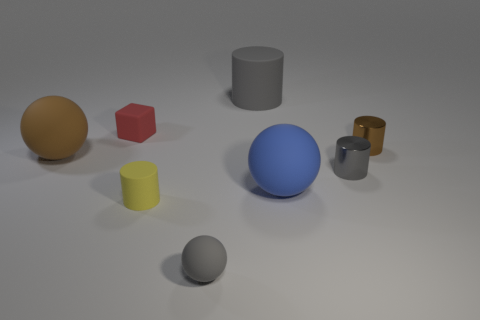Subtract all gray spheres. How many spheres are left? 2 Add 2 small metal cylinders. How many objects exist? 10 Subtract all yellow blocks. Subtract all purple spheres. How many blocks are left? 1 Subtract all brown blocks. How many yellow cylinders are left? 1 Subtract all small gray matte spheres. Subtract all brown metallic cylinders. How many objects are left? 6 Add 1 brown metal objects. How many brown metal objects are left? 2 Add 5 blue matte balls. How many blue matte balls exist? 6 Subtract all brown balls. How many balls are left? 2 Subtract 0 cyan cylinders. How many objects are left? 8 Subtract all spheres. How many objects are left? 5 